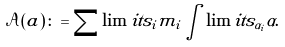<formula> <loc_0><loc_0><loc_500><loc_500>\mathcal { A } ( a ) \colon = \sum \lim i t s _ { i } m _ { i } \int \lim i t s _ { \alpha _ { i } } \alpha .</formula> 